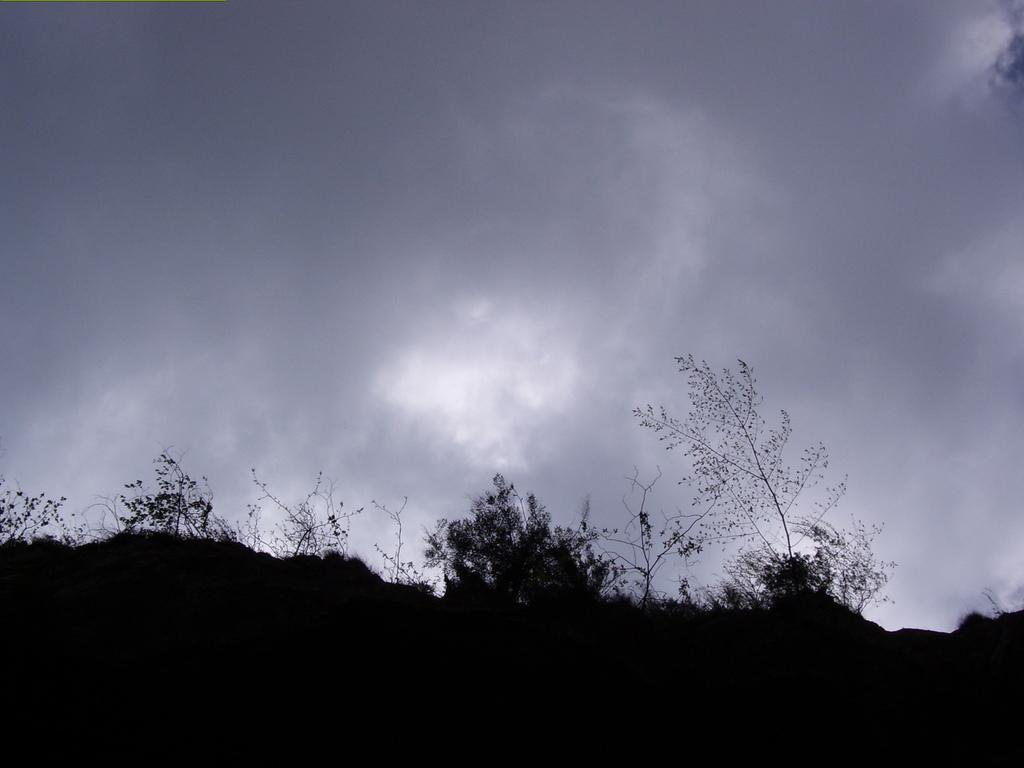What type of vegetation can be seen in the image? There are trees in the image. What is visible in the background of the image? The sky is visible in the background of the image. What can be observed in the sky? Clouds are present in the sky. What type of lumber is being used to build the fog in the image? There is no fog or lumber present in the image; it features trees and a sky with clouds. 